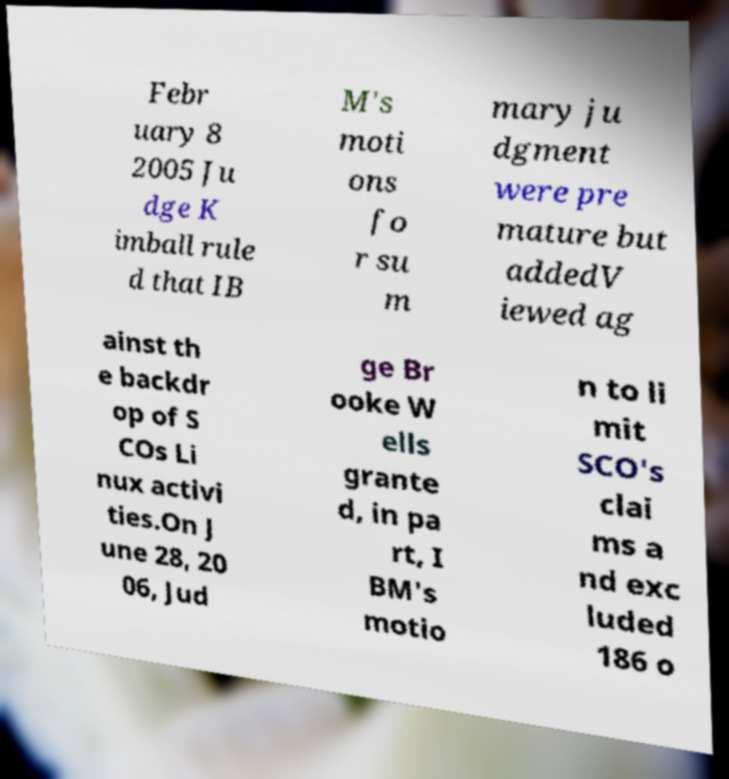Can you read and provide the text displayed in the image?This photo seems to have some interesting text. Can you extract and type it out for me? Febr uary 8 2005 Ju dge K imball rule d that IB M's moti ons fo r su m mary ju dgment were pre mature but addedV iewed ag ainst th e backdr op of S COs Li nux activi ties.On J une 28, 20 06, Jud ge Br ooke W ells grante d, in pa rt, I BM's motio n to li mit SCO's clai ms a nd exc luded 186 o 